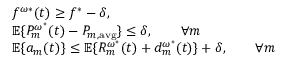<formula> <loc_0><loc_0><loc_500><loc_500>\begin{array} { r l } & { f ^ { \omega * } ( t ) \geq f ^ { * } - \delta , } \\ & { \mathbb { E } \{ P _ { m } ^ { \omega ^ { * } } ( t ) - P _ { m , a v g } \} \leq \delta , \quad \forall m } \\ & { \mathbb { E } \{ a _ { m } ( t ) \} \leq \mathbb { E } \{ R _ { m } ^ { \omega ^ { * } } ( t ) + d _ { m } ^ { \omega ^ { * } } ( t ) \} + \delta , \quad \forall m } \end{array}</formula> 